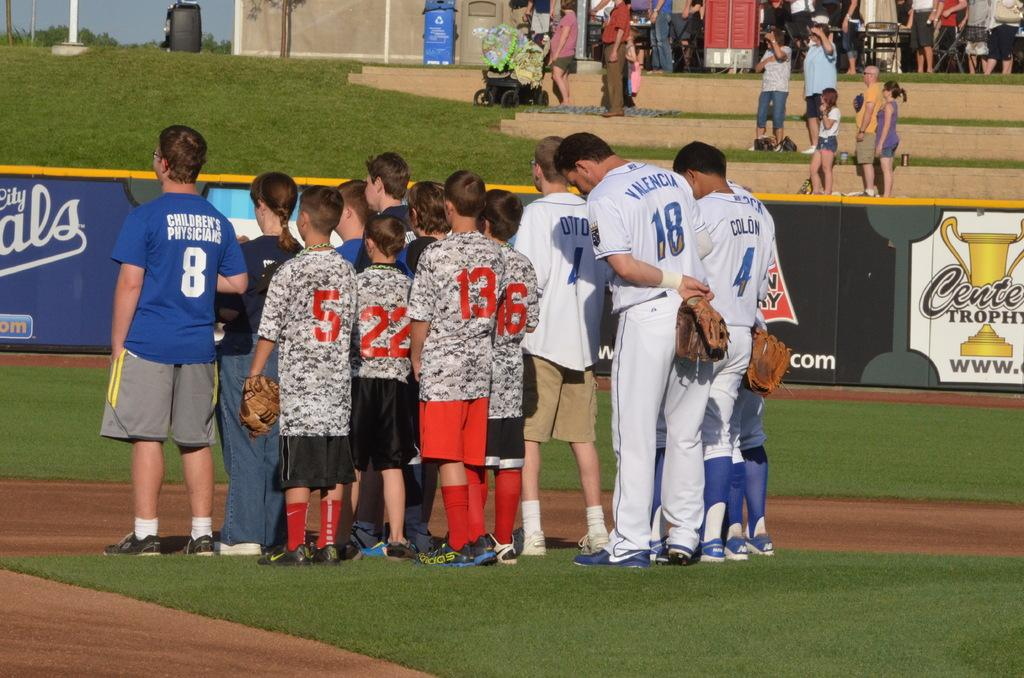<image>
Present a compact description of the photo's key features. Baseball player number 4 stands with his back to the camera with other baseball players and children. 